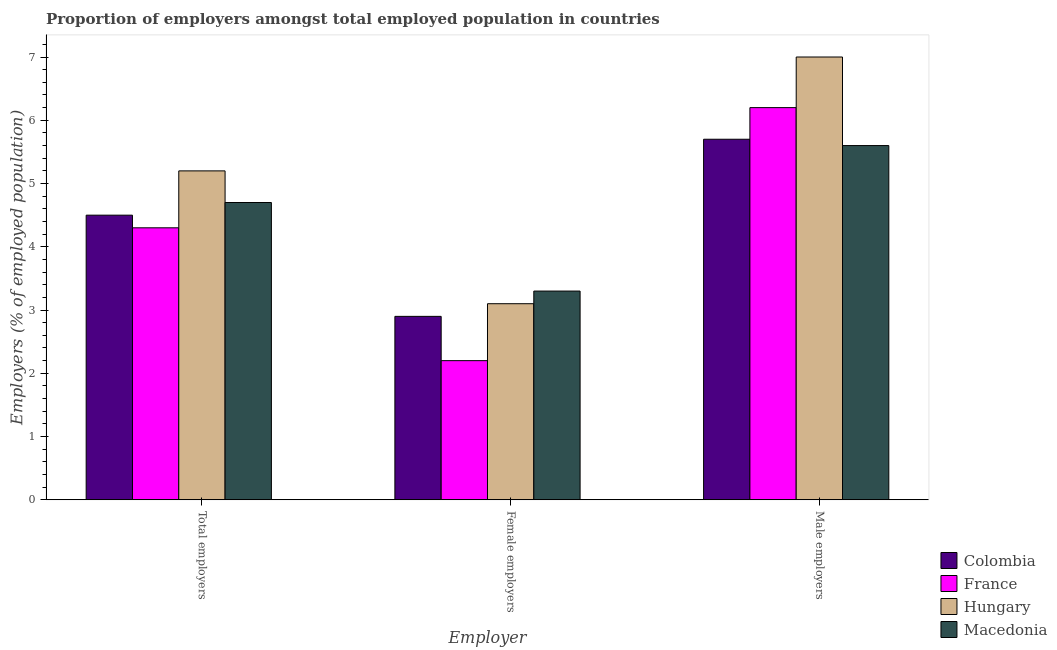Are the number of bars per tick equal to the number of legend labels?
Your answer should be compact. Yes. Are the number of bars on each tick of the X-axis equal?
Provide a succinct answer. Yes. How many bars are there on the 3rd tick from the right?
Your answer should be compact. 4. What is the label of the 3rd group of bars from the left?
Offer a very short reply. Male employers. What is the percentage of female employers in Hungary?
Your answer should be compact. 3.1. Across all countries, what is the maximum percentage of total employers?
Offer a very short reply. 5.2. Across all countries, what is the minimum percentage of female employers?
Provide a short and direct response. 2.2. In which country was the percentage of female employers maximum?
Offer a very short reply. Macedonia. In which country was the percentage of male employers minimum?
Keep it short and to the point. Macedonia. What is the total percentage of male employers in the graph?
Give a very brief answer. 24.5. What is the difference between the percentage of female employers in Hungary and that in Colombia?
Give a very brief answer. 0.2. What is the difference between the percentage of female employers in Colombia and the percentage of total employers in Macedonia?
Provide a short and direct response. -1.8. What is the average percentage of total employers per country?
Provide a short and direct response. 4.67. What is the difference between the percentage of female employers and percentage of total employers in Macedonia?
Offer a very short reply. -1.4. In how many countries, is the percentage of female employers greater than 6.2 %?
Your response must be concise. 0. What is the ratio of the percentage of total employers in France to that in Hungary?
Ensure brevity in your answer.  0.83. Is the difference between the percentage of female employers in Macedonia and Hungary greater than the difference between the percentage of total employers in Macedonia and Hungary?
Keep it short and to the point. Yes. What is the difference between the highest and the second highest percentage of male employers?
Keep it short and to the point. 0.8. What is the difference between the highest and the lowest percentage of total employers?
Offer a terse response. 0.9. What does the 3rd bar from the left in Total employers represents?
Provide a succinct answer. Hungary. What does the 3rd bar from the right in Female employers represents?
Offer a terse response. France. How many bars are there?
Give a very brief answer. 12. Are all the bars in the graph horizontal?
Make the answer very short. No. How many countries are there in the graph?
Make the answer very short. 4. Are the values on the major ticks of Y-axis written in scientific E-notation?
Your answer should be compact. No. Does the graph contain any zero values?
Make the answer very short. No. How many legend labels are there?
Offer a terse response. 4. What is the title of the graph?
Offer a terse response. Proportion of employers amongst total employed population in countries. What is the label or title of the X-axis?
Give a very brief answer. Employer. What is the label or title of the Y-axis?
Keep it short and to the point. Employers (% of employed population). What is the Employers (% of employed population) in France in Total employers?
Your answer should be compact. 4.3. What is the Employers (% of employed population) of Hungary in Total employers?
Offer a very short reply. 5.2. What is the Employers (% of employed population) of Macedonia in Total employers?
Give a very brief answer. 4.7. What is the Employers (% of employed population) in Colombia in Female employers?
Ensure brevity in your answer.  2.9. What is the Employers (% of employed population) of France in Female employers?
Your answer should be very brief. 2.2. What is the Employers (% of employed population) of Hungary in Female employers?
Your answer should be compact. 3.1. What is the Employers (% of employed population) of Macedonia in Female employers?
Offer a very short reply. 3.3. What is the Employers (% of employed population) in Colombia in Male employers?
Your answer should be very brief. 5.7. What is the Employers (% of employed population) of France in Male employers?
Your response must be concise. 6.2. What is the Employers (% of employed population) in Macedonia in Male employers?
Offer a terse response. 5.6. Across all Employer, what is the maximum Employers (% of employed population) in Colombia?
Offer a terse response. 5.7. Across all Employer, what is the maximum Employers (% of employed population) of France?
Give a very brief answer. 6.2. Across all Employer, what is the maximum Employers (% of employed population) of Hungary?
Your answer should be very brief. 7. Across all Employer, what is the maximum Employers (% of employed population) in Macedonia?
Ensure brevity in your answer.  5.6. Across all Employer, what is the minimum Employers (% of employed population) of Colombia?
Offer a terse response. 2.9. Across all Employer, what is the minimum Employers (% of employed population) in France?
Make the answer very short. 2.2. Across all Employer, what is the minimum Employers (% of employed population) in Hungary?
Provide a succinct answer. 3.1. Across all Employer, what is the minimum Employers (% of employed population) of Macedonia?
Make the answer very short. 3.3. What is the total Employers (% of employed population) of Colombia in the graph?
Your response must be concise. 13.1. What is the total Employers (% of employed population) in France in the graph?
Make the answer very short. 12.7. What is the total Employers (% of employed population) in Hungary in the graph?
Your answer should be compact. 15.3. What is the difference between the Employers (% of employed population) of France in Total employers and that in Female employers?
Keep it short and to the point. 2.1. What is the difference between the Employers (% of employed population) of Colombia in Total employers and that in Male employers?
Provide a succinct answer. -1.2. What is the difference between the Employers (% of employed population) in Macedonia in Female employers and that in Male employers?
Your response must be concise. -2.3. What is the difference between the Employers (% of employed population) in Colombia in Total employers and the Employers (% of employed population) in Hungary in Female employers?
Provide a succinct answer. 1.4. What is the difference between the Employers (% of employed population) of France in Total employers and the Employers (% of employed population) of Hungary in Female employers?
Your answer should be very brief. 1.2. What is the difference between the Employers (% of employed population) in Hungary in Total employers and the Employers (% of employed population) in Macedonia in Female employers?
Your answer should be very brief. 1.9. What is the difference between the Employers (% of employed population) in Colombia in Total employers and the Employers (% of employed population) in France in Male employers?
Keep it short and to the point. -1.7. What is the difference between the Employers (% of employed population) in Hungary in Total employers and the Employers (% of employed population) in Macedonia in Male employers?
Keep it short and to the point. -0.4. What is the difference between the Employers (% of employed population) in Colombia in Female employers and the Employers (% of employed population) in France in Male employers?
Provide a short and direct response. -3.3. What is the difference between the Employers (% of employed population) of Colombia in Female employers and the Employers (% of employed population) of Macedonia in Male employers?
Offer a terse response. -2.7. What is the difference between the Employers (% of employed population) in France in Female employers and the Employers (% of employed population) in Hungary in Male employers?
Keep it short and to the point. -4.8. What is the average Employers (% of employed population) in Colombia per Employer?
Ensure brevity in your answer.  4.37. What is the average Employers (% of employed population) in France per Employer?
Keep it short and to the point. 4.23. What is the average Employers (% of employed population) of Hungary per Employer?
Keep it short and to the point. 5.1. What is the average Employers (% of employed population) of Macedonia per Employer?
Offer a terse response. 4.53. What is the difference between the Employers (% of employed population) of Colombia and Employers (% of employed population) of Macedonia in Total employers?
Provide a succinct answer. -0.2. What is the difference between the Employers (% of employed population) of Hungary and Employers (% of employed population) of Macedonia in Total employers?
Offer a terse response. 0.5. What is the difference between the Employers (% of employed population) of Colombia and Employers (% of employed population) of France in Female employers?
Make the answer very short. 0.7. What is the difference between the Employers (% of employed population) of Colombia and Employers (% of employed population) of Hungary in Female employers?
Keep it short and to the point. -0.2. What is the difference between the Employers (% of employed population) in France and Employers (% of employed population) in Hungary in Female employers?
Your response must be concise. -0.9. What is the difference between the Employers (% of employed population) of France and Employers (% of employed population) of Macedonia in Female employers?
Your answer should be compact. -1.1. What is the difference between the Employers (% of employed population) in Colombia and Employers (% of employed population) in France in Male employers?
Provide a succinct answer. -0.5. What is the difference between the Employers (% of employed population) in Colombia and Employers (% of employed population) in Hungary in Male employers?
Offer a terse response. -1.3. What is the difference between the Employers (% of employed population) of Colombia and Employers (% of employed population) of Macedonia in Male employers?
Give a very brief answer. 0.1. What is the difference between the Employers (% of employed population) of France and Employers (% of employed population) of Hungary in Male employers?
Provide a short and direct response. -0.8. What is the difference between the Employers (% of employed population) of France and Employers (% of employed population) of Macedonia in Male employers?
Give a very brief answer. 0.6. What is the difference between the Employers (% of employed population) in Hungary and Employers (% of employed population) in Macedonia in Male employers?
Give a very brief answer. 1.4. What is the ratio of the Employers (% of employed population) of Colombia in Total employers to that in Female employers?
Ensure brevity in your answer.  1.55. What is the ratio of the Employers (% of employed population) in France in Total employers to that in Female employers?
Provide a succinct answer. 1.95. What is the ratio of the Employers (% of employed population) in Hungary in Total employers to that in Female employers?
Make the answer very short. 1.68. What is the ratio of the Employers (% of employed population) of Macedonia in Total employers to that in Female employers?
Keep it short and to the point. 1.42. What is the ratio of the Employers (% of employed population) in Colombia in Total employers to that in Male employers?
Your answer should be compact. 0.79. What is the ratio of the Employers (% of employed population) in France in Total employers to that in Male employers?
Ensure brevity in your answer.  0.69. What is the ratio of the Employers (% of employed population) of Hungary in Total employers to that in Male employers?
Ensure brevity in your answer.  0.74. What is the ratio of the Employers (% of employed population) of Macedonia in Total employers to that in Male employers?
Offer a terse response. 0.84. What is the ratio of the Employers (% of employed population) in Colombia in Female employers to that in Male employers?
Your answer should be very brief. 0.51. What is the ratio of the Employers (% of employed population) of France in Female employers to that in Male employers?
Provide a short and direct response. 0.35. What is the ratio of the Employers (% of employed population) in Hungary in Female employers to that in Male employers?
Your answer should be very brief. 0.44. What is the ratio of the Employers (% of employed population) in Macedonia in Female employers to that in Male employers?
Provide a short and direct response. 0.59. What is the difference between the highest and the second highest Employers (% of employed population) in France?
Give a very brief answer. 1.9. What is the difference between the highest and the second highest Employers (% of employed population) in Macedonia?
Make the answer very short. 0.9. What is the difference between the highest and the lowest Employers (% of employed population) of Hungary?
Give a very brief answer. 3.9. 